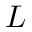<formula> <loc_0><loc_0><loc_500><loc_500>L</formula> 